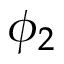<formula> <loc_0><loc_0><loc_500><loc_500>\phi _ { 2 }</formula> 